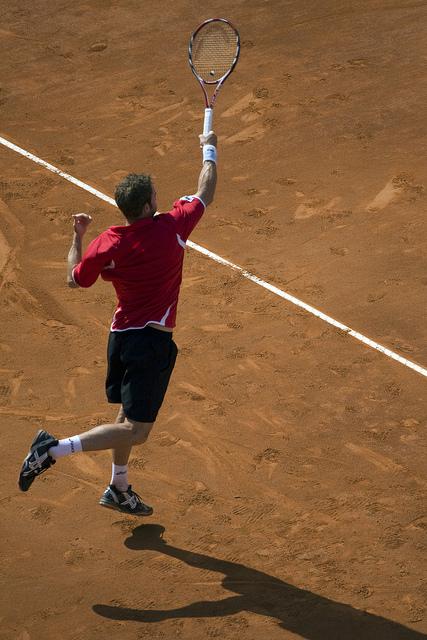What brand is the tennis racket?
Keep it brief. Wilson. What is the person holding?
Keep it brief. Tennis racket. What is the tennis court made of?
Concise answer only. Dirt. 